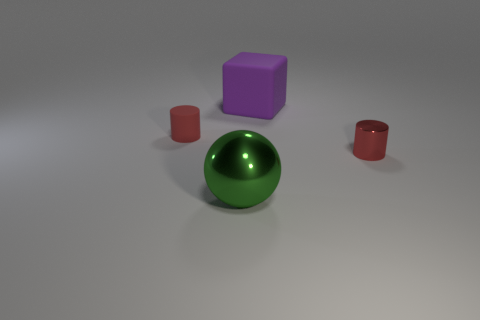What shape is the big object that is behind the metal object that is in front of the small red object that is on the right side of the purple thing?
Make the answer very short. Cube. What material is the object that is behind the small metallic object and in front of the large purple thing?
Your answer should be very brief. Rubber. What shape is the red rubber thing that is to the left of the large object that is in front of the small red matte cylinder?
Offer a terse response. Cylinder. Are there any other things of the same color as the tiny rubber thing?
Keep it short and to the point. Yes. There is a metal sphere; is its size the same as the matte thing that is on the right side of the green sphere?
Your response must be concise. Yes. What number of tiny objects are either purple rubber cubes or gray metallic spheres?
Keep it short and to the point. 0. Are there more green spheres than tiny purple shiny cylinders?
Ensure brevity in your answer.  Yes. What number of big metal objects are behind the red object that is on the left side of the big metal ball that is on the left side of the metal cylinder?
Your answer should be compact. 0. What shape is the green metal object?
Give a very brief answer. Sphere. What number of other objects are the same material as the big purple object?
Make the answer very short. 1. 